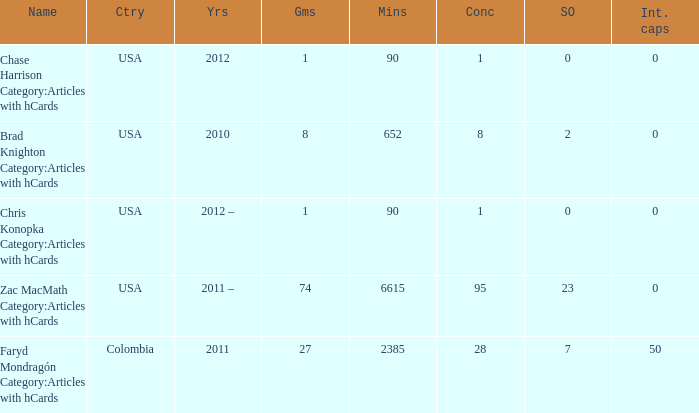When 2010 is the year what is the game? 8.0. 